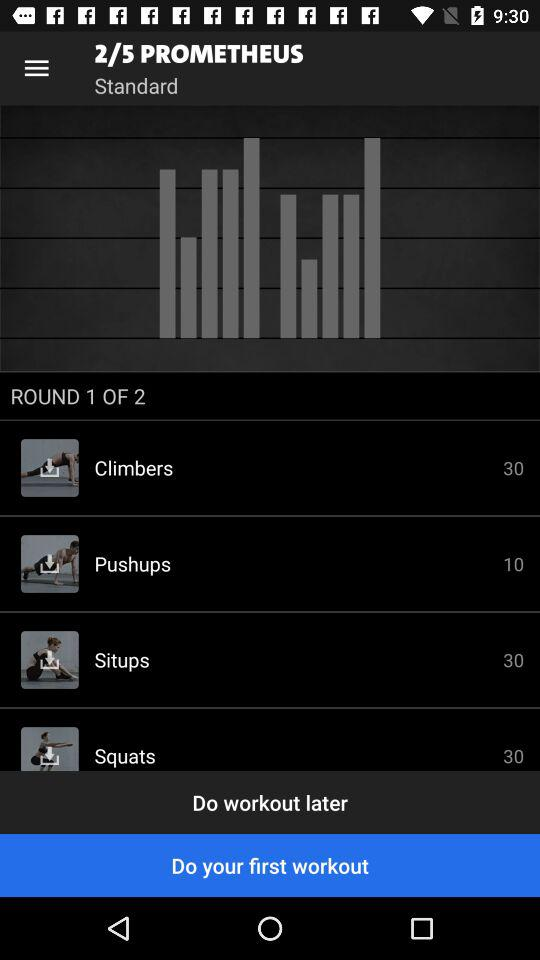How many exercises are there in round 1?
Answer the question using a single word or phrase. 4 